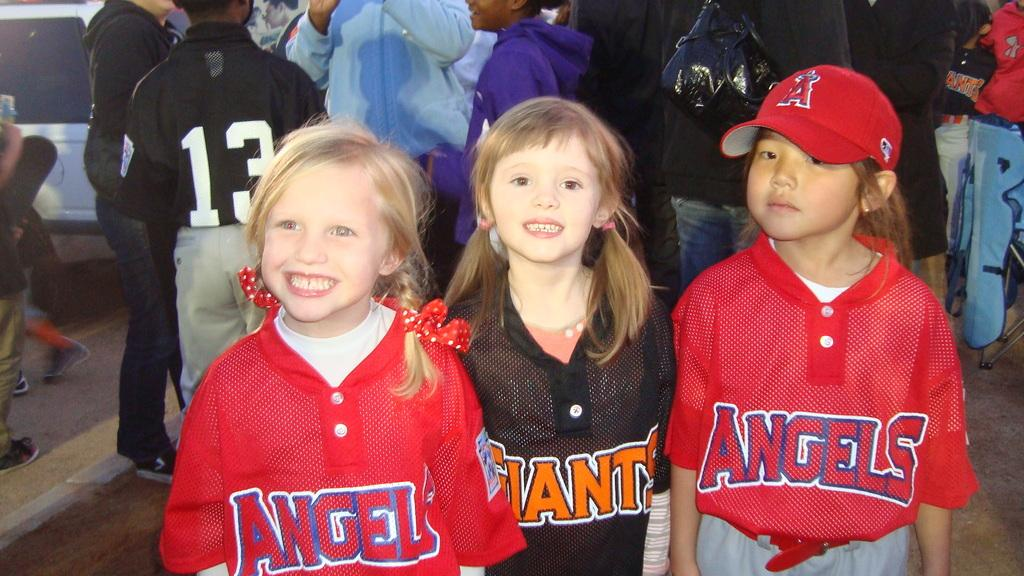<image>
Present a compact description of the photo's key features. two children with angle jerseys and one wearing the giants 